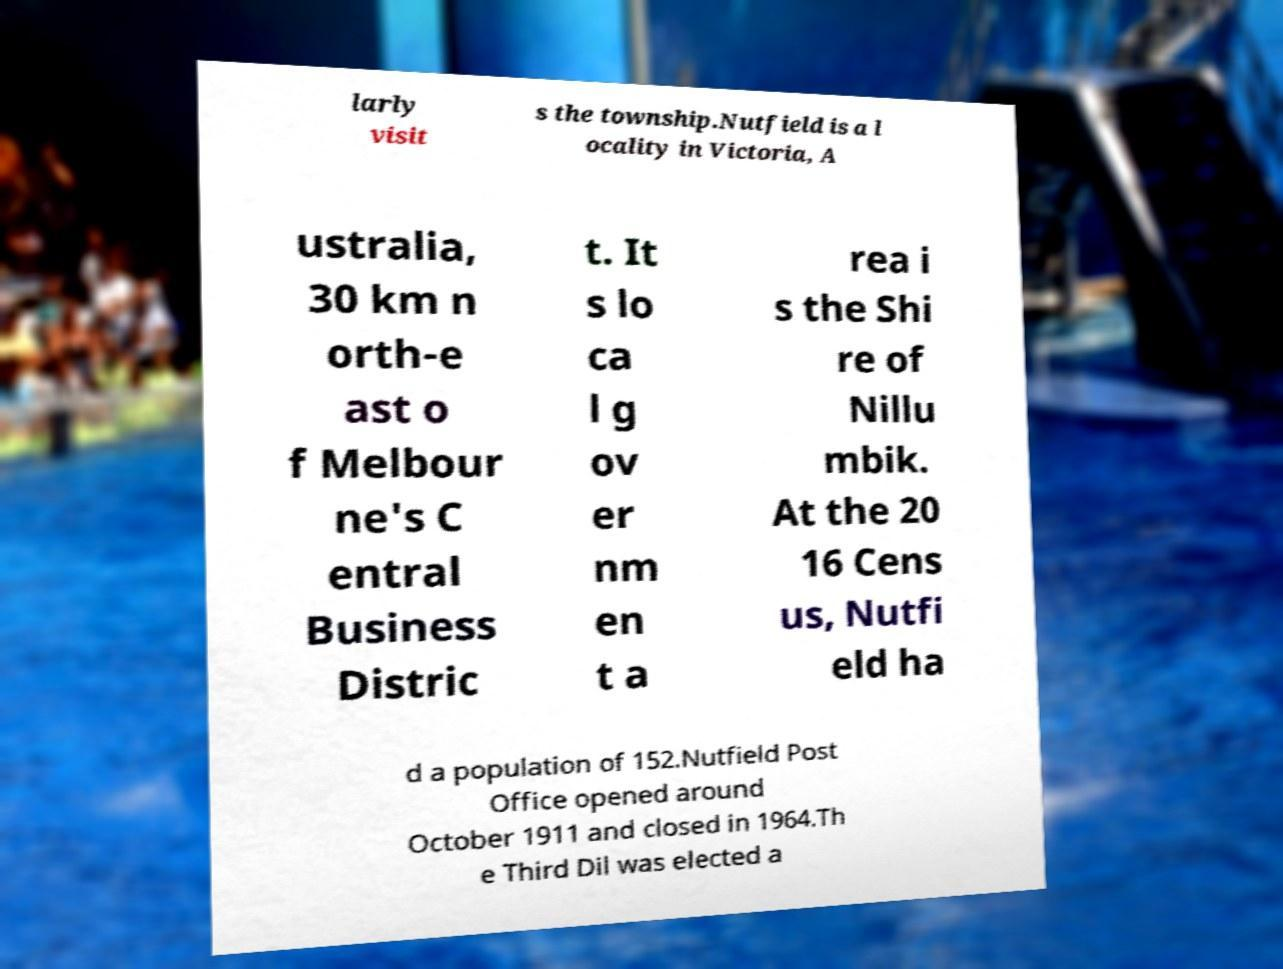There's text embedded in this image that I need extracted. Can you transcribe it verbatim? larly visit s the township.Nutfield is a l ocality in Victoria, A ustralia, 30 km n orth-e ast o f Melbour ne's C entral Business Distric t. It s lo ca l g ov er nm en t a rea i s the Shi re of Nillu mbik. At the 20 16 Cens us, Nutfi eld ha d a population of 152.Nutfield Post Office opened around October 1911 and closed in 1964.Th e Third Dil was elected a 